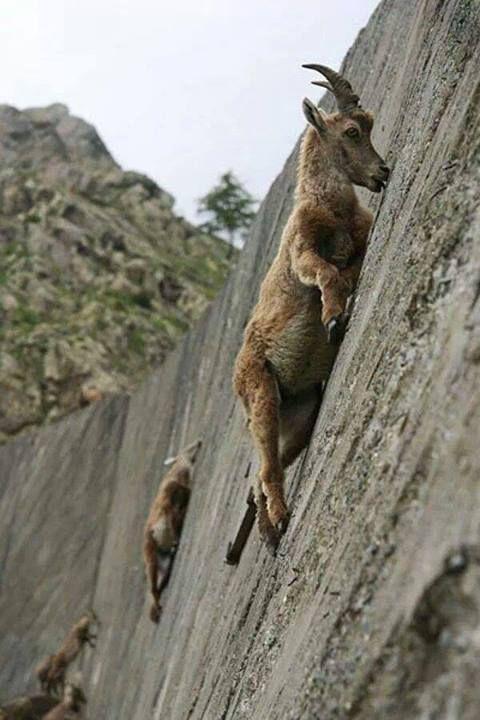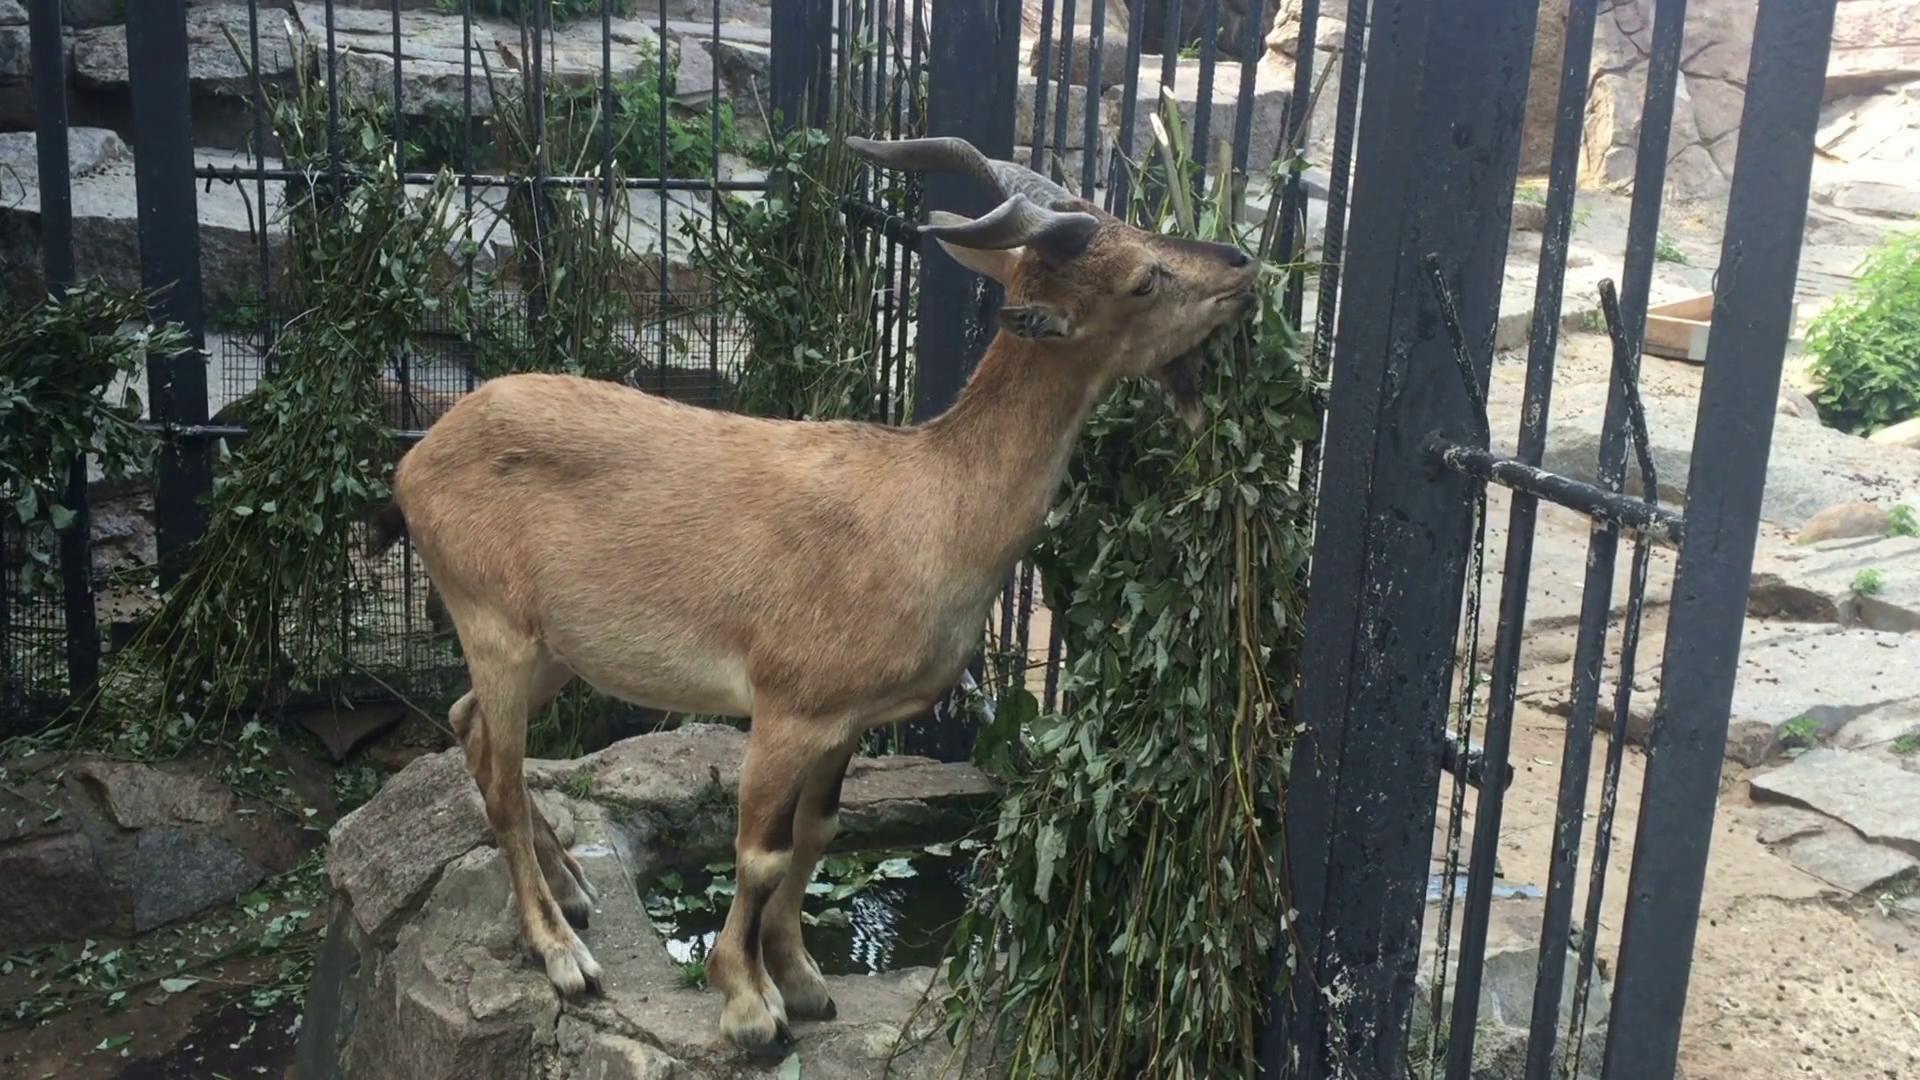The first image is the image on the left, the second image is the image on the right. For the images shown, is this caption "exactly one goat is in the image to the right, eating grass." true? Answer yes or no. Yes. The first image is the image on the left, the second image is the image on the right. Evaluate the accuracy of this statement regarding the images: "An image contains at least two hooved animals in an area with green foliage, with at least one animal upright on all fours.". Is it true? Answer yes or no. No. 